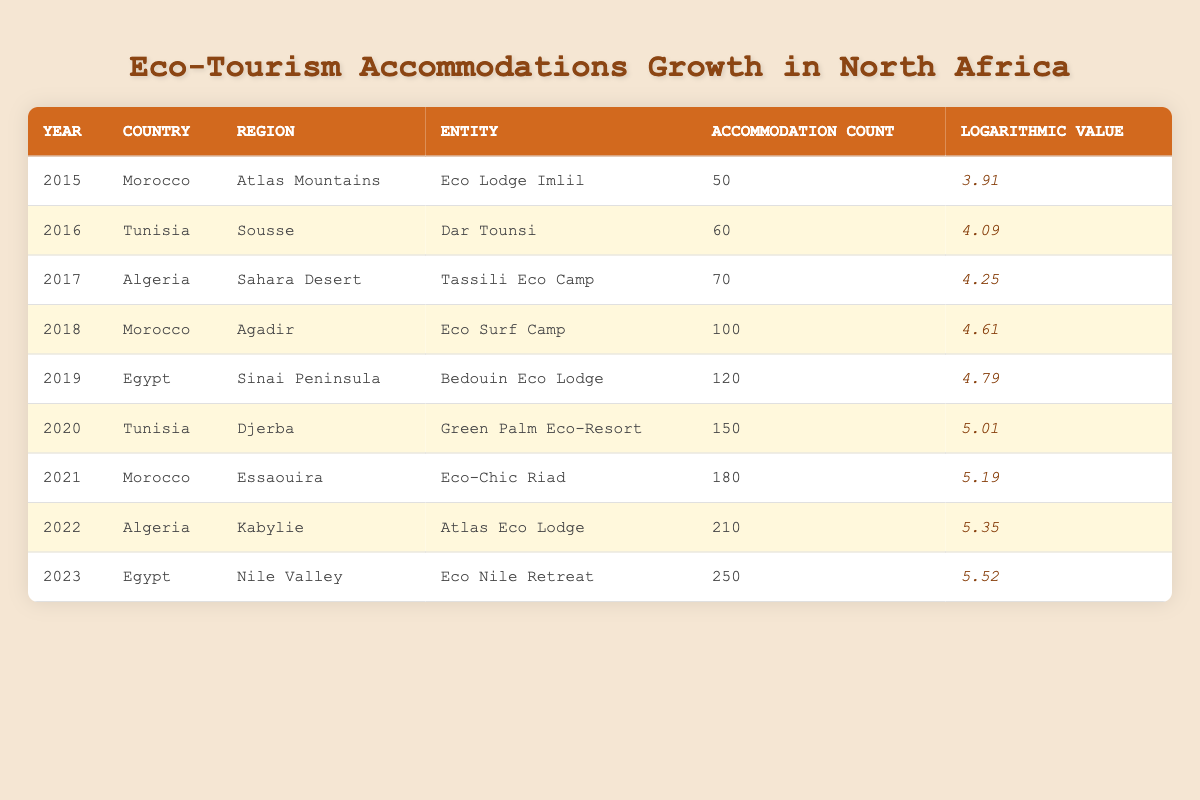What is the accommodation count for the year 2020? The table lists the accommodation count for each year. In the row for 2020, the value is directly provided as 150.
Answer: 150 Which country had the highest accommodation count in 2023? By examining the table, I can see that in 2023, Egypt has the highest accommodation count listed at 250.
Answer: Egypt What is the average accommodation count between the years 2019 and 2022? I find the accommodation counts for 2019 (120), 2020 (150), 2021 (180), and 2022 (210). Summing these values gives 120 + 150 + 180 + 210 = 660. Given that there are 4 years, the average is 660 divided by 4, which is 165.
Answer: 165 Did Morocco increase its eco-tourism accommodations from 2015 to 2021? Looking at the table, the accommodation count in Morocco increased from 50 in 2015 to 180 in 2021. Thus, it shows a growth over these years.
Answer: Yes Which region in Algeria had the most eco-tourism accommodations in the data provided? Examining the table for Algeria, I see two entries: the Sahara Desert in 2017 with 70 accommodations and Kabylie in 2022 with 210 accommodations. The latter number is higher, indicating Kabylie had more eco-tourism accommodations.
Answer: Kabylie What is the difference in accommodation counts between the lowest and highest years listed? To find this, I determine the lowest accommodation count in 2015 (50) and the highest in 2023 (250). The difference is 250 - 50 = 200.
Answer: 200 How many accommodations were there in Tunisia in total from 2016 to 2020? I identify the counts for Tunisia: 60 in 2016, 150 in 2020. Adding these counts gives 60 + 150 = 210.
Answer: 210 Is the logarithmic value for the year 2016 higher than that for 2019? Checking the provided logarithmic values, 2016 has a log value of 4.09 and 2019 has 4.79. Since 4.09 is less than 4.79, the answer is straightforward.
Answer: No Which year experienced the largest single-year growth in eco-tourism accommodations from the previous year? I calculate the growth between each consecutive year by subtracting the accommodation counts: 2015 to 2016 (10), 2016 to 2017 (10), 2017 to 2018 (30), 2018 to 2019 (20), 2019 to 2020 (30), 2020 to 2021 (30), 2021 to 2022 (30), and finally 2022 to 2023 (40). The largest growth occurred from 2022 to 2023, which is 40 accommodations.
Answer: 40 